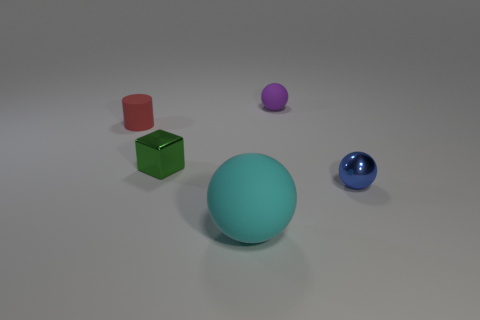What number of metallic objects are either big objects or small yellow cylinders?
Make the answer very short. 0. There is a cyan matte thing that is the same shape as the tiny purple object; what is its size?
Your answer should be compact. Large. Is there any other thing that is the same size as the rubber cylinder?
Your answer should be very brief. Yes. There is a green block; is its size the same as the rubber sphere behind the shiny block?
Your response must be concise. Yes. The tiny shiny thing on the left side of the purple rubber sphere has what shape?
Provide a succinct answer. Cube. What is the color of the ball that is behind the small rubber object on the left side of the cyan object?
Your answer should be compact. Purple. What is the color of the other matte object that is the same shape as the cyan object?
Offer a terse response. Purple. There is a small shiny sphere; is its color the same as the rubber thing in front of the green metallic object?
Your answer should be very brief. No. There is a matte object that is behind the cyan ball and left of the purple rubber ball; what shape is it?
Provide a succinct answer. Cylinder. What is the material of the small blue thing that is on the right side of the purple rubber ball that is behind the ball that is left of the purple rubber object?
Ensure brevity in your answer.  Metal. 